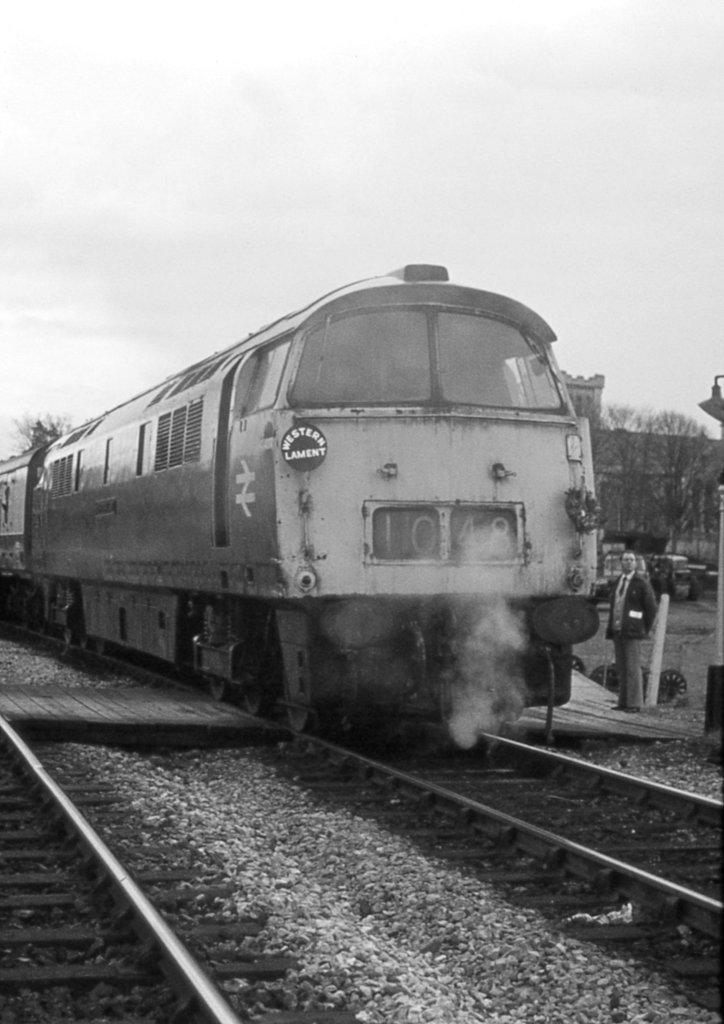What is the main subject of the image? The main subject of the image is a train. Where is the train located in the image? The train is on a track. What can be seen in the background of the image? There are trees, at least one building, and the sky visible in the background of the image. What is present at the bottom of the image? There are railway tracks at the bottom of the image. Can you tell me how many keys are hanging from the bat in the image? There are no keys or bats present in the image; it features a train on a track with trees, buildings, and the sky in the background. 